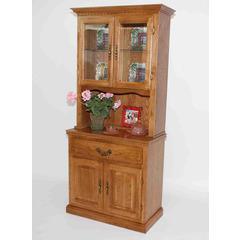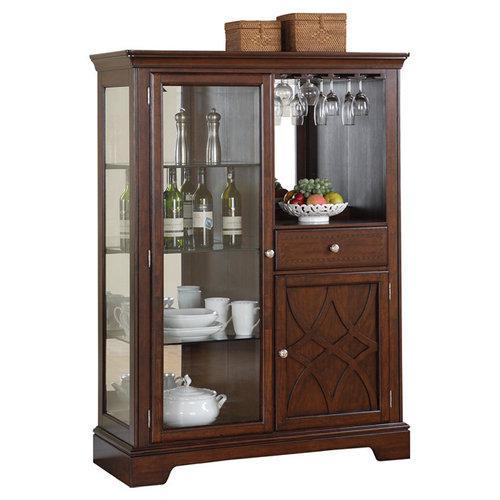The first image is the image on the left, the second image is the image on the right. Examine the images to the left and right. Is the description "The cabinet in the image on the right is bare." accurate? Answer yes or no. No. The first image is the image on the left, the second image is the image on the right. Given the left and right images, does the statement "There is no less than one hutch that is completely empty" hold true? Answer yes or no. No. 